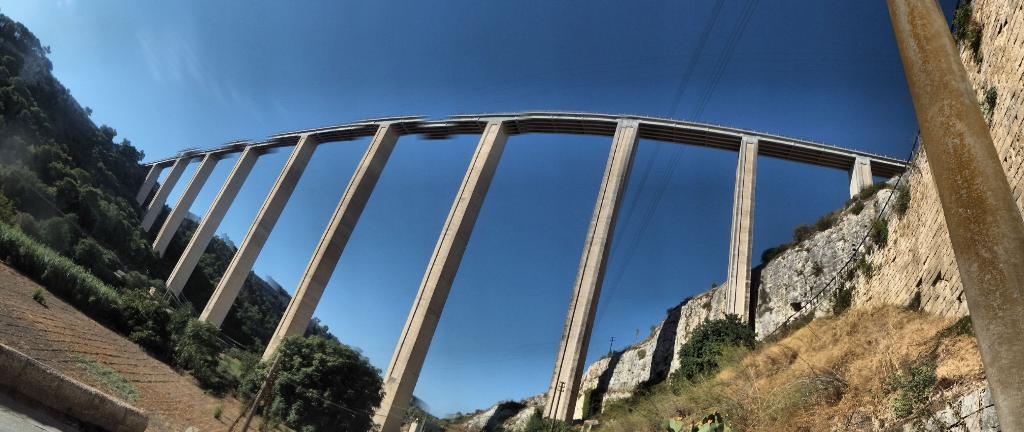How would you summarize this image in a sentence or two? In this picture we can observe a bridge. There are some pillars. We can observe some plants and trees on the ground. On the right side we can observe a pole. In the background we can observe a hill and a sky. 